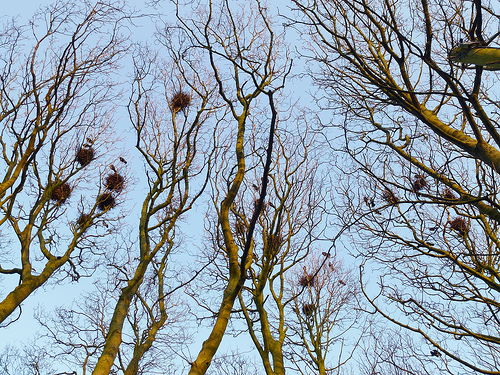<image>
Is the tree next to the sky? Yes. The tree is positioned adjacent to the sky, located nearby in the same general area. 